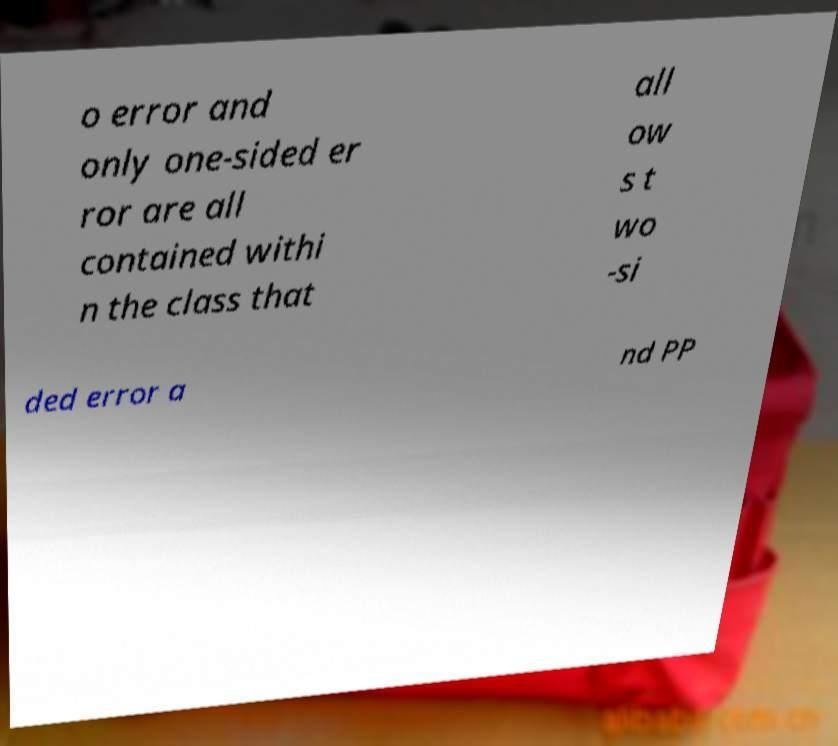Please read and relay the text visible in this image. What does it say? o error and only one-sided er ror are all contained withi n the class that all ow s t wo -si ded error a nd PP 